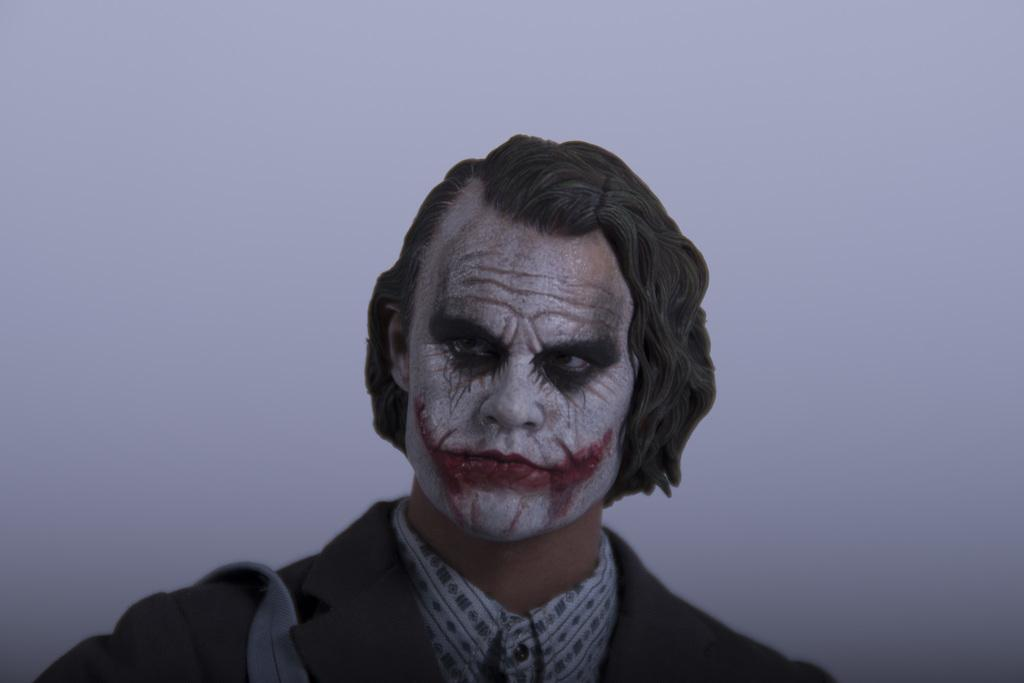What is the main subject of the image? There is a person in the image. What can be observed about the person's clothing? The person is wearing a black color jacket. What type of design can be seen on the chalk in the image? There is no chalk present in the image, so it is not possible to determine the design on it. 